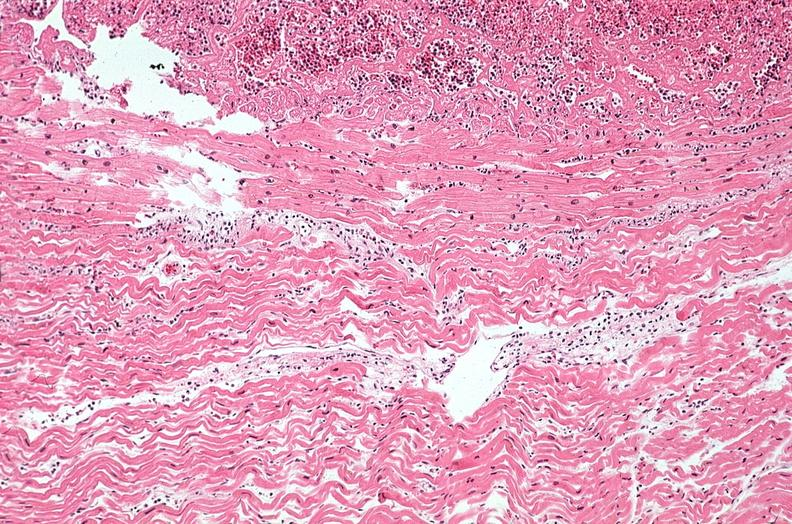what is present?
Answer the question using a single word or phrase. Heart 